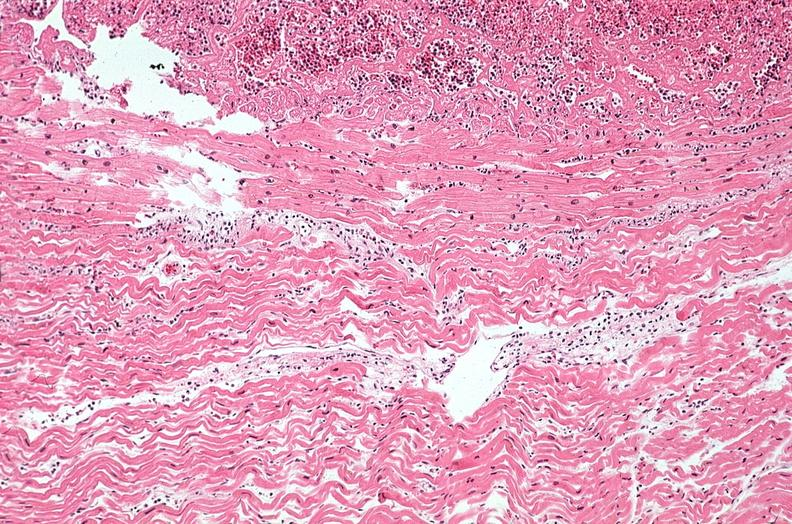what is present?
Answer the question using a single word or phrase. Heart 